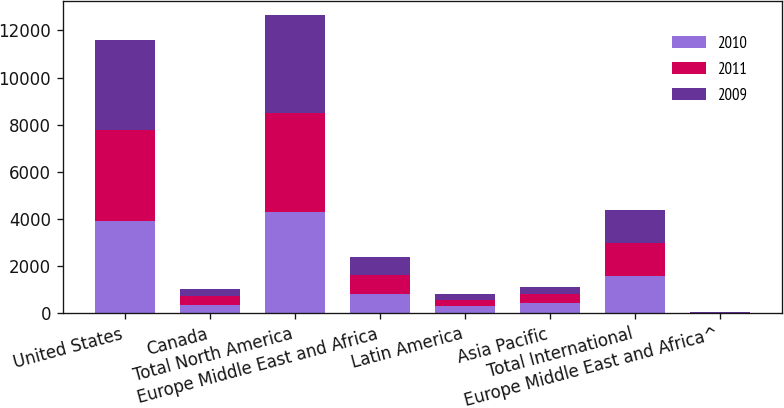Convert chart to OTSL. <chart><loc_0><loc_0><loc_500><loc_500><stacked_bar_chart><ecel><fcel>United States<fcel>Canada<fcel>Total North America<fcel>Europe Middle East and Africa<fcel>Latin America<fcel>Asia Pacific<fcel>Total International<fcel>Europe Middle East and Africa^<nl><fcel>2010<fcel>3915.7<fcel>376.3<fcel>4292<fcel>815.3<fcel>318.6<fcel>438.7<fcel>1572.6<fcel>16.6<nl><fcel>2011<fcel>3870.3<fcel>351<fcel>4221.3<fcel>800.5<fcel>267<fcel>369.4<fcel>1436.9<fcel>10<nl><fcel>2009<fcel>3806.8<fcel>317.6<fcel>4124.4<fcel>791<fcel>259.5<fcel>308.5<fcel>1359<fcel>19.7<nl></chart> 